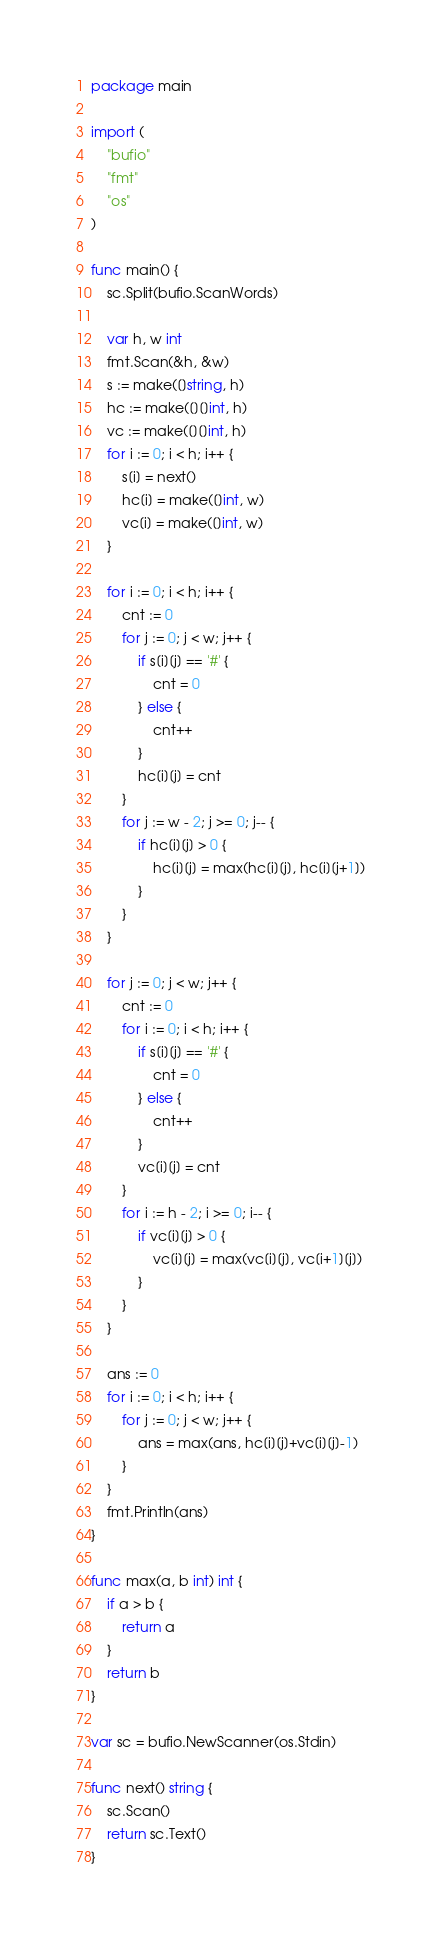<code> <loc_0><loc_0><loc_500><loc_500><_Go_>package main

import (
	"bufio"
	"fmt"
	"os"
)

func main() {
	sc.Split(bufio.ScanWords)

	var h, w int
	fmt.Scan(&h, &w)
	s := make([]string, h)
	hc := make([][]int, h)
	vc := make([][]int, h)
	for i := 0; i < h; i++ {
		s[i] = next()
		hc[i] = make([]int, w)
		vc[i] = make([]int, w)
	}

	for i := 0; i < h; i++ {
		cnt := 0
		for j := 0; j < w; j++ {
			if s[i][j] == '#' {
				cnt = 0
			} else {
				cnt++
			}
			hc[i][j] = cnt
		}
		for j := w - 2; j >= 0; j-- {
			if hc[i][j] > 0 {
				hc[i][j] = max(hc[i][j], hc[i][j+1])
			}
		}
	}

	for j := 0; j < w; j++ {
		cnt := 0
		for i := 0; i < h; i++ {
			if s[i][j] == '#' {
				cnt = 0
			} else {
				cnt++
			}
			vc[i][j] = cnt
		}
		for i := h - 2; i >= 0; i-- {
			if vc[i][j] > 0 {
				vc[i][j] = max(vc[i][j], vc[i+1][j])
			}
		}
	}

	ans := 0
	for i := 0; i < h; i++ {
		for j := 0; j < w; j++ {
			ans = max(ans, hc[i][j]+vc[i][j]-1)
		}
	}
	fmt.Println(ans)
}

func max(a, b int) int {
	if a > b {
		return a
	}
	return b
}

var sc = bufio.NewScanner(os.Stdin)

func next() string {
	sc.Scan()
	return sc.Text()
}
</code> 